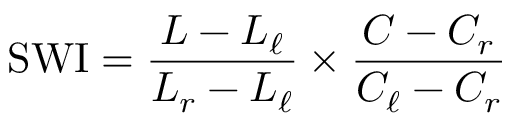Convert formula to latex. <formula><loc_0><loc_0><loc_500><loc_500>{ S W I } = { \frac { L - L _ { \ell } } { L _ { r } - L _ { \ell } } } \times { \frac { C - C _ { r } } { C _ { \ell } - C _ { r } } }</formula> 